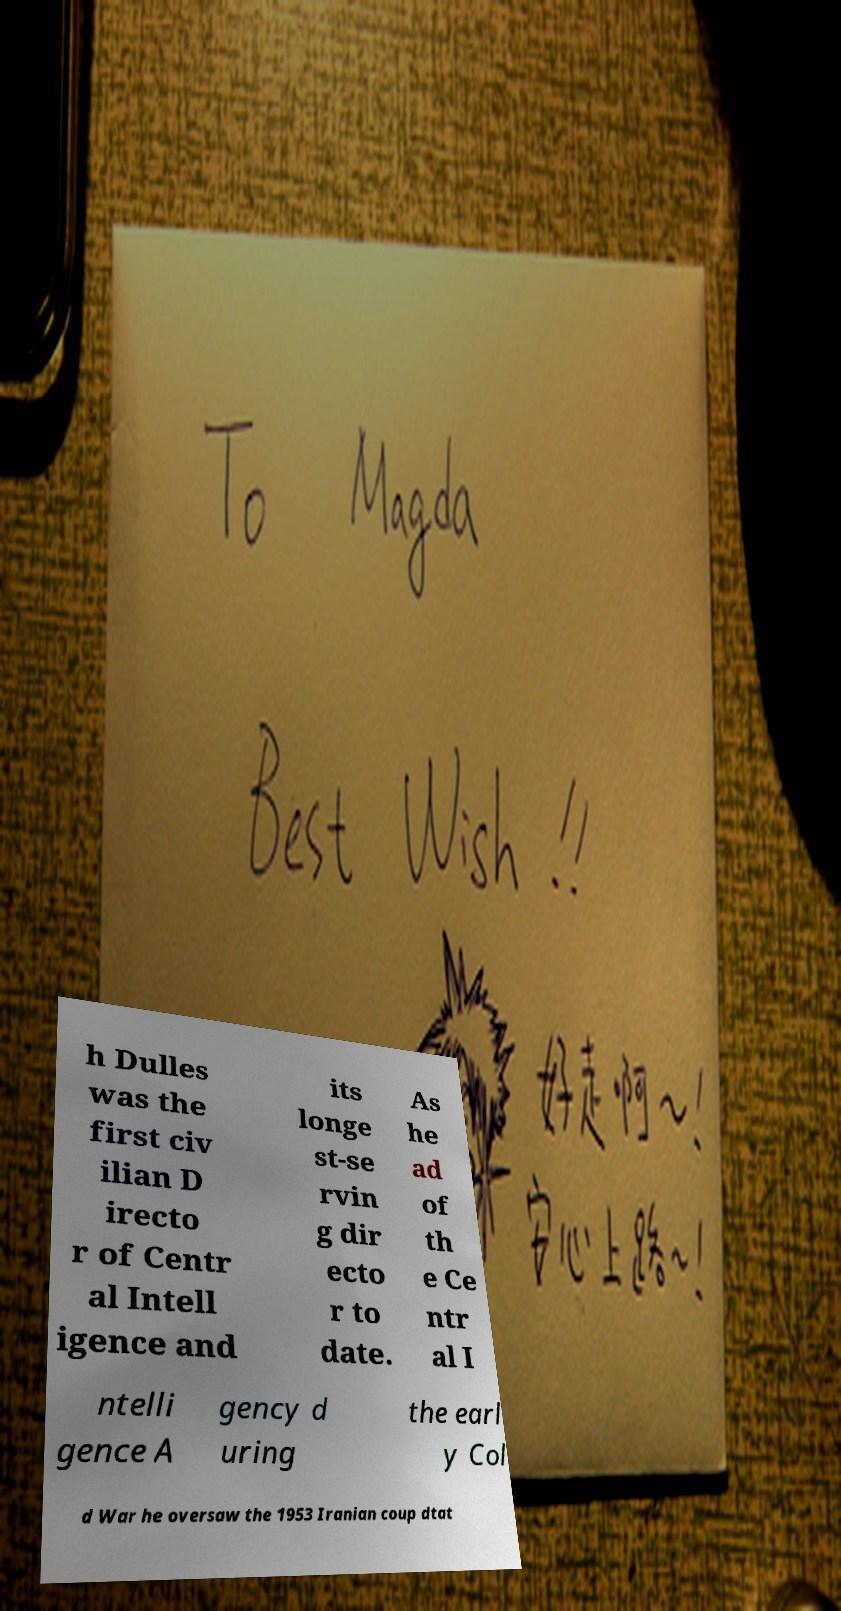Could you assist in decoding the text presented in this image and type it out clearly? h Dulles was the first civ ilian D irecto r of Centr al Intell igence and its longe st-se rvin g dir ecto r to date. As he ad of th e Ce ntr al I ntelli gence A gency d uring the earl y Col d War he oversaw the 1953 Iranian coup dtat 